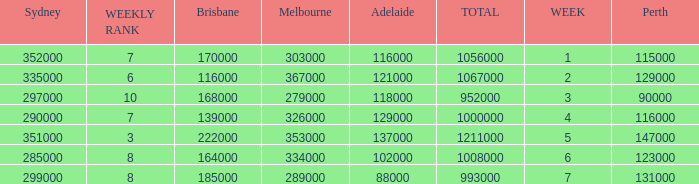How many Adelaide viewers were there in Week 5? 137000.0. 